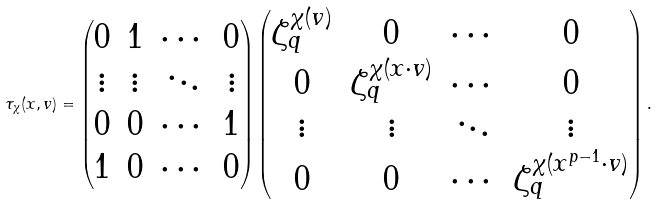<formula> <loc_0><loc_0><loc_500><loc_500>\tau _ { \chi } ( x , v ) = \begin{pmatrix} 0 & 1 & \cdots & 0 \\ \vdots & \vdots & \ddots & \vdots \\ 0 & 0 & \cdots & 1 \\ 1 & 0 & \cdots & 0 \end{pmatrix} \begin{pmatrix} \zeta _ { q } ^ { \chi ( v ) } & 0 & \cdots & 0 \\ 0 & \zeta _ { q } ^ { \chi ( x \cdot v ) } & \cdots & 0 \\ \vdots & \vdots & \ddots & \vdots \\ 0 & 0 & \cdots & \zeta _ { q } ^ { \chi ( x ^ { p - 1 } \cdot v ) } \end{pmatrix} .</formula> 